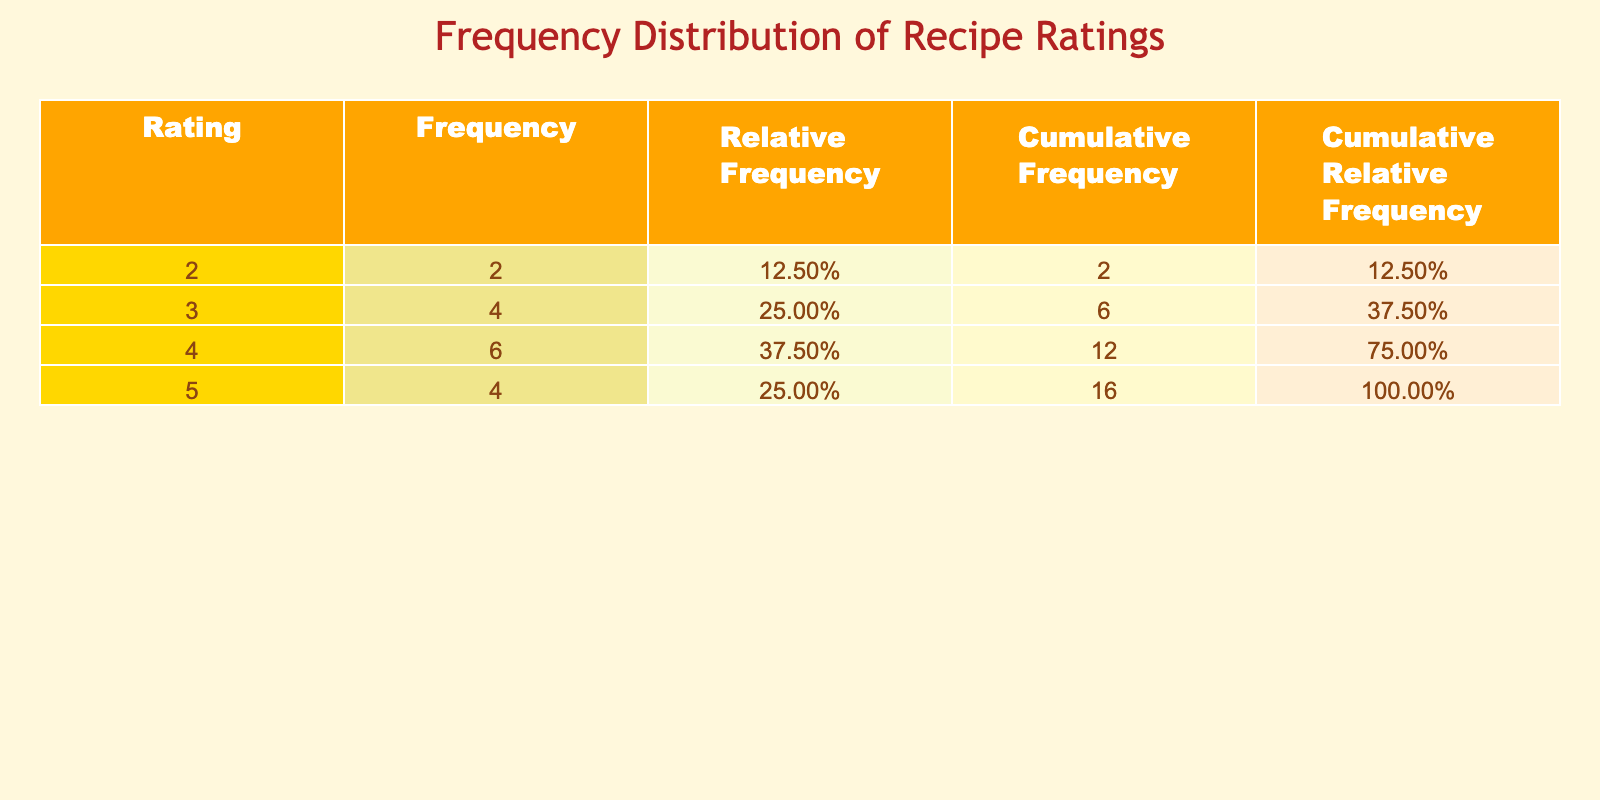What is the frequency of recipes rated 5? From the table, the frequency of recipes rated 5 is shown in the 'Frequency' column corresponding to the Rating of 5. There are 4 instances of recipes with a rating of 5: Big Mac Burger, Spicy McChicken, McFlurry, and McCafe Mocha.
Answer: 4 What is the total number of recipes evaluated? The total number of recipes evaluated can be found by counting all the entries in the table. By reviewing the data provided, there are 15 recipes listed.
Answer: 15 Is there a recipe with a rating of 1? To answer this, we need to check the 'Rating' column in the table. Since the ratings are from 2 to 5 and do not include a rating of 1, the answer is no.
Answer: No What is the relative frequency of recipes rated 4? The relative frequency is determined by dividing the count of recipes rated 4 by the total number of recipes. There are 5 recipes rated 4, so the relative frequency is 5/15, which equals 0.3333.
Answer: 0.33 What is the cumulative frequency of ratings less than 4? To find this, sum the frequencies of the ratings 2 and 3. The frequency of recipes rated 2 is 2, and the frequency for recipes rated 3 is 4. Adding these gives 2 + 4 = 6.
Answer: 6 What is the average rating of all the recipes listed? To find the average rating, we first multiply each rating by its frequency and then sum these products. The total is (5*4) + (4*5) + (3*4) + (2*2) = 20 + 20 + 12 + 4 = 56. Then we divide by the number of recipes, which is 15. So the average is 56/15 = 3.7333.
Answer: 3.73 Which rating has the highest cumulative relative frequency, and what is its value? To determine this, we need to look at the 'Cumulative Relative Frequency' column. The highest rating of 5 has a cumulative relative frequency of 0.7333 (or 73.33%), as it includes all ratings up to and including 5.
Answer: 0.73 How many recipes are rated lower than the Quarter Pounder with Cheese? The rating for the Quarter Pounder with Cheese is 4. Thus, we consider ratings lower than 4: which are 2 and 3. Adding their frequencies: recipes rated 2 (2) + recipes rated 3 (4) sums to 6.
Answer: 6 What proportion of recipes received a rating of 3? To find this, we look at the frequency of recipes rated 3 and divide it by the total number of recipes. There are 4 recipes rated 3, so the proportion is 4/15, which equals approximately 0.2667.
Answer: 0.27 